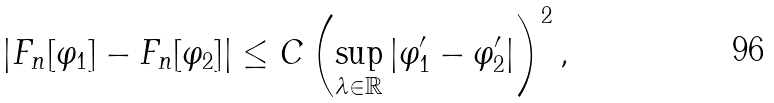<formula> <loc_0><loc_0><loc_500><loc_500>| F _ { n } [ \varphi _ { 1 } ] - F _ { n } [ \varphi _ { 2 } ] | \leq C \left ( \sup _ { \lambda \in \mathbb { R } } | \varphi _ { 1 } ^ { \prime } - \varphi _ { 2 } ^ { \prime } | \right ) ^ { 2 } ,</formula> 